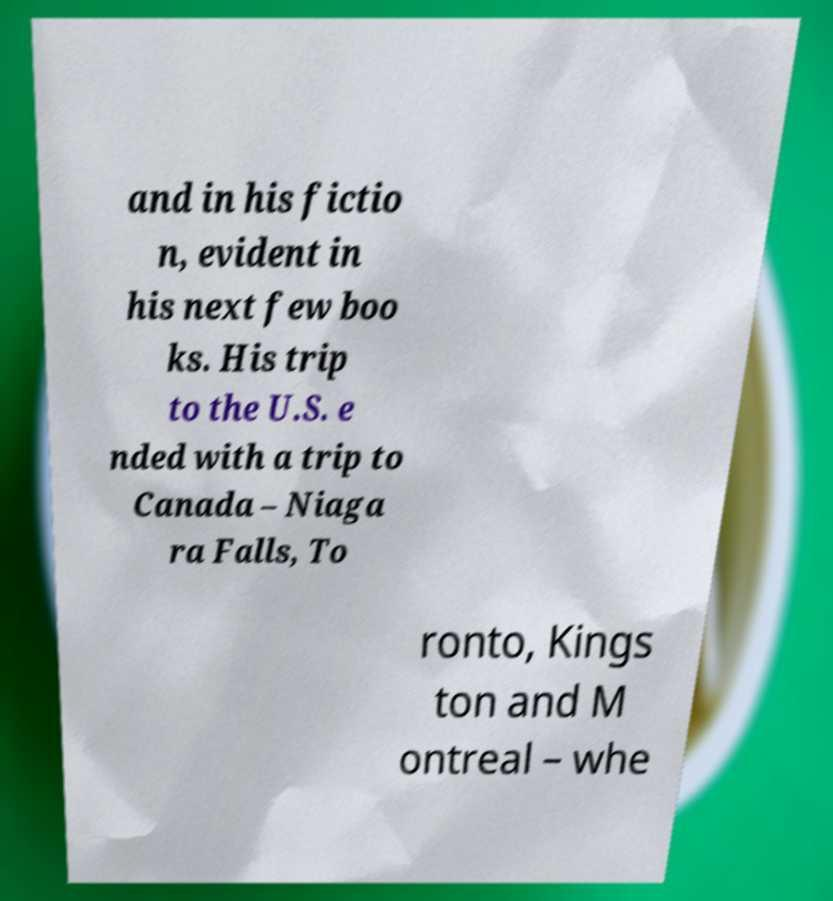Could you assist in decoding the text presented in this image and type it out clearly? and in his fictio n, evident in his next few boo ks. His trip to the U.S. e nded with a trip to Canada – Niaga ra Falls, To ronto, Kings ton and M ontreal – whe 